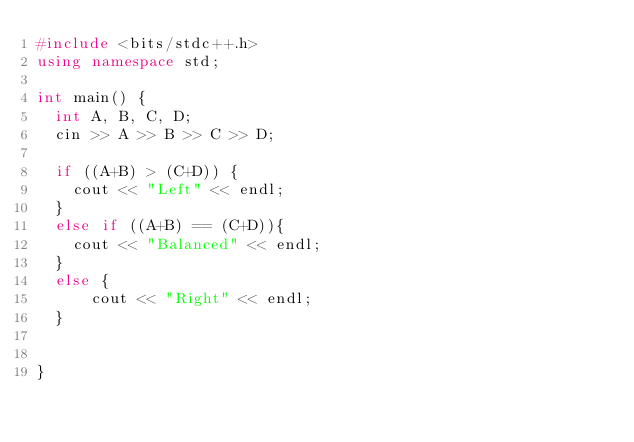Convert code to text. <code><loc_0><loc_0><loc_500><loc_500><_C++_>#include <bits/stdc++.h>
using namespace std;

int main() {
  int A, B, C, D;
  cin >> A >> B >> C >> D;

  if ((A+B) > (C+D)) {
    cout << "Left" << endl;
  }
  else if ((A+B) == (C+D)){
    cout << "Balanced" << endl;
  }
  else {
      cout << "Right" << endl;
  }
  

}</code> 